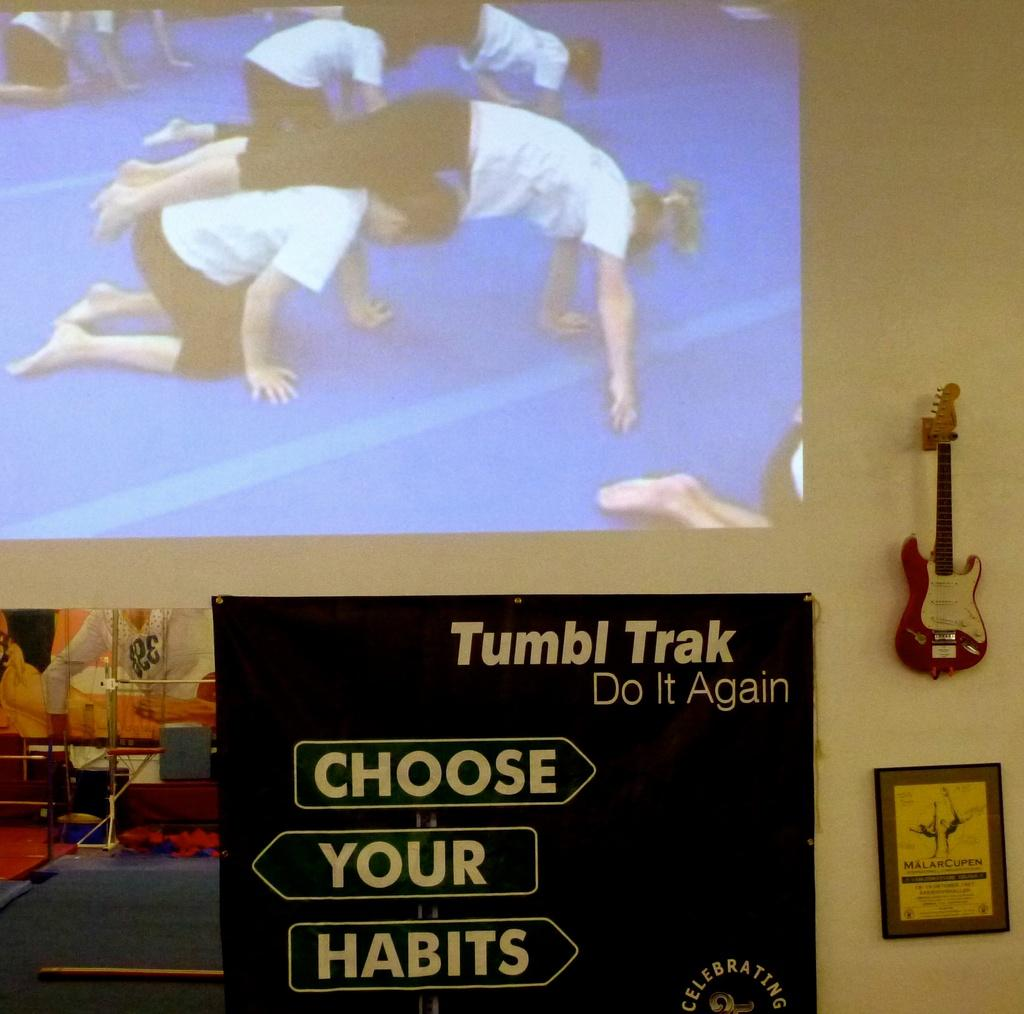What objects are on the wall in the image? There are boards, a frame, a guitar, and a screen on the wall in the image. What type of object is the frame surrounding? The frame is surrounding a guitar in the image. What is the purpose of the screen on the wall? The purpose of the screen is not specified in the image, but it could be a television or a monitor. Are there any people present in the image? Yes, there are people in the image. What songs are the people singing in the image? There is no indication in the image that the people are singing, so it cannot be determined which songs they might be singing. 